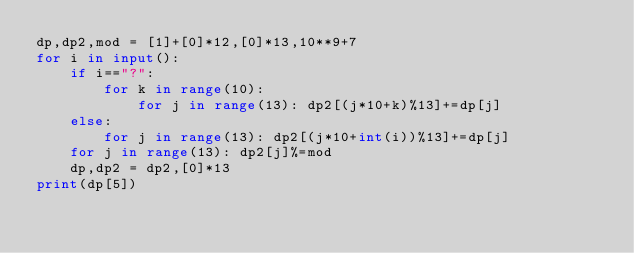<code> <loc_0><loc_0><loc_500><loc_500><_Python_>dp,dp2,mod = [1]+[0]*12,[0]*13,10**9+7
for i in input():
    if i=="?":
        for k in range(10):
            for j in range(13): dp2[(j*10+k)%13]+=dp[j]
    else:
        for j in range(13): dp2[(j*10+int(i))%13]+=dp[j]
    for j in range(13): dp2[j]%=mod
    dp,dp2 = dp2,[0]*13
print(dp[5])</code> 